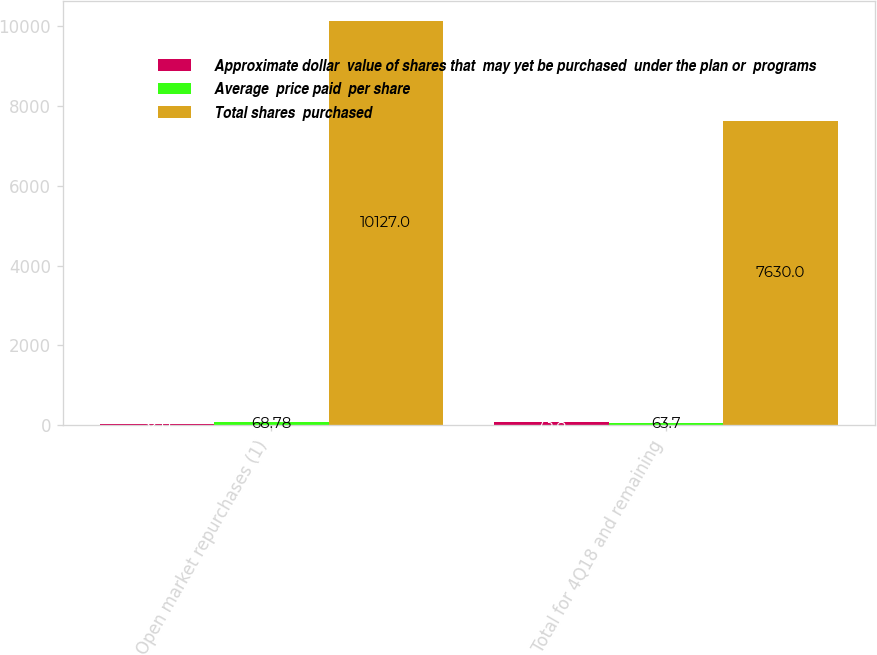Convert chart to OTSL. <chart><loc_0><loc_0><loc_500><loc_500><stacked_bar_chart><ecel><fcel>Open market repurchases (1)<fcel>Total for 4Q18 and remaining<nl><fcel>Approximate dollar  value of shares that  may yet be purchased  under the plan or  programs<fcel>32<fcel>73.8<nl><fcel>Average  price paid  per share<fcel>68.78<fcel>63.7<nl><fcel>Total shares  purchased<fcel>10127<fcel>7630<nl></chart> 